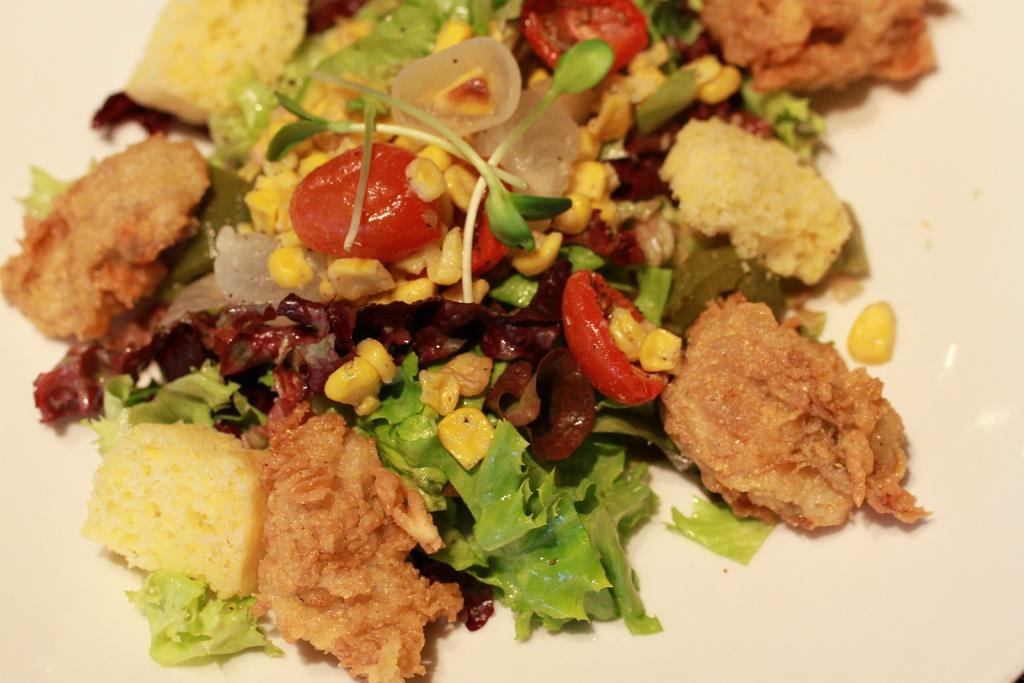What can be seen in the image related to food? There is food visible in the image. Can you tell me how many patches are on the food in the image? There is no mention of patches on the food in the image, so it cannot be determined from the provided information. 